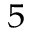Convert formula to latex. <formula><loc_0><loc_0><loc_500><loc_500>_ { 5 }</formula> 